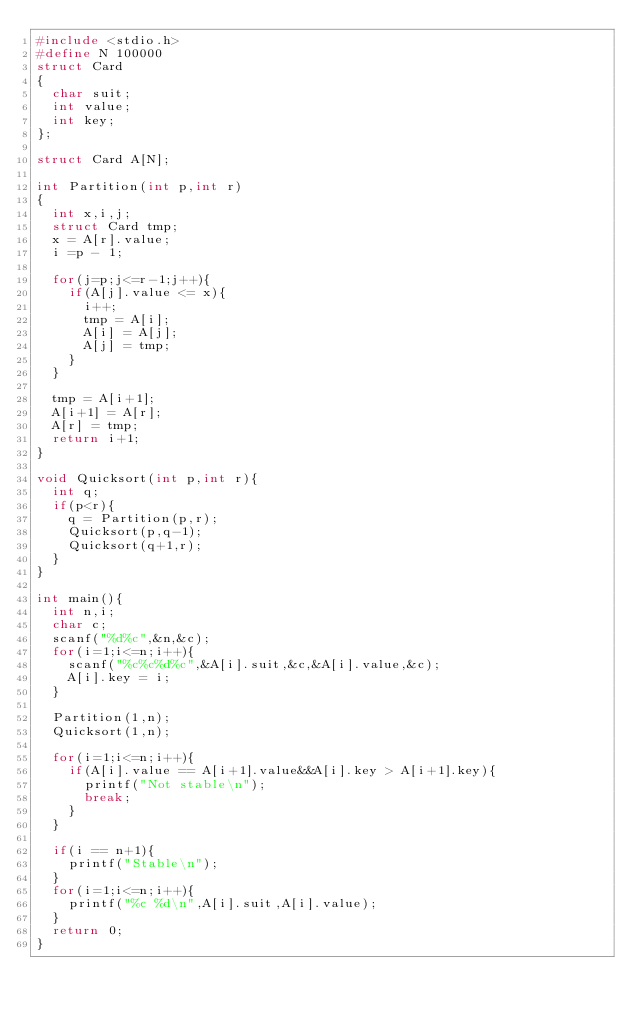Convert code to text. <code><loc_0><loc_0><loc_500><loc_500><_C_>#include <stdio.h>
#define N 100000
struct Card
{
  char suit;
  int value;
  int key;
};

struct Card A[N];

int Partition(int p,int r)
{
  int x,i,j;
  struct Card tmp;
  x = A[r].value;
  i =p - 1;

  for(j=p;j<=r-1;j++){
    if(A[j].value <= x){
      i++;
      tmp = A[i];
      A[i] = A[j];
      A[j] = tmp;
    }
  }

  tmp = A[i+1];
  A[i+1] = A[r];
  A[r] = tmp;
  return i+1;
}

void Quicksort(int p,int r){
  int q;
  if(p<r){
    q = Partition(p,r);
    Quicksort(p,q-1);
    Quicksort(q+1,r);
  }
}

int main(){
  int n,i;
  char c;
  scanf("%d%c",&n,&c);
  for(i=1;i<=n;i++){
    scanf("%c%c%d%c",&A[i].suit,&c,&A[i].value,&c);
    A[i].key = i;
  }

  Partition(1,n);
  Quicksort(1,n);

  for(i=1;i<=n;i++){
    if(A[i].value == A[i+1].value&&A[i].key > A[i+1].key){
      printf("Not stable\n");
      break;
    }
  }

  if(i == n+1){
    printf("Stable\n");
  }
  for(i=1;i<=n;i++){
    printf("%c %d\n",A[i].suit,A[i].value);
  }
  return 0;
}</code> 